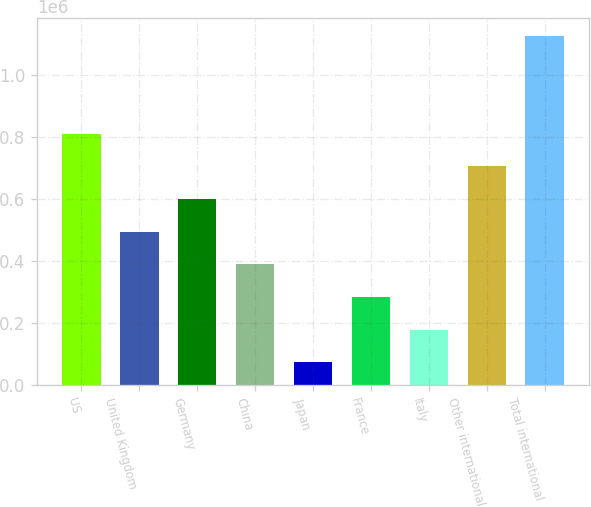<chart> <loc_0><loc_0><loc_500><loc_500><bar_chart><fcel>US<fcel>United Kingdom<fcel>Germany<fcel>China<fcel>Japan<fcel>France<fcel>Italy<fcel>Other international<fcel>Total international<nl><fcel>811438<fcel>495047<fcel>600510<fcel>389584<fcel>73193<fcel>284120<fcel>178656<fcel>705974<fcel>1.12783e+06<nl></chart> 